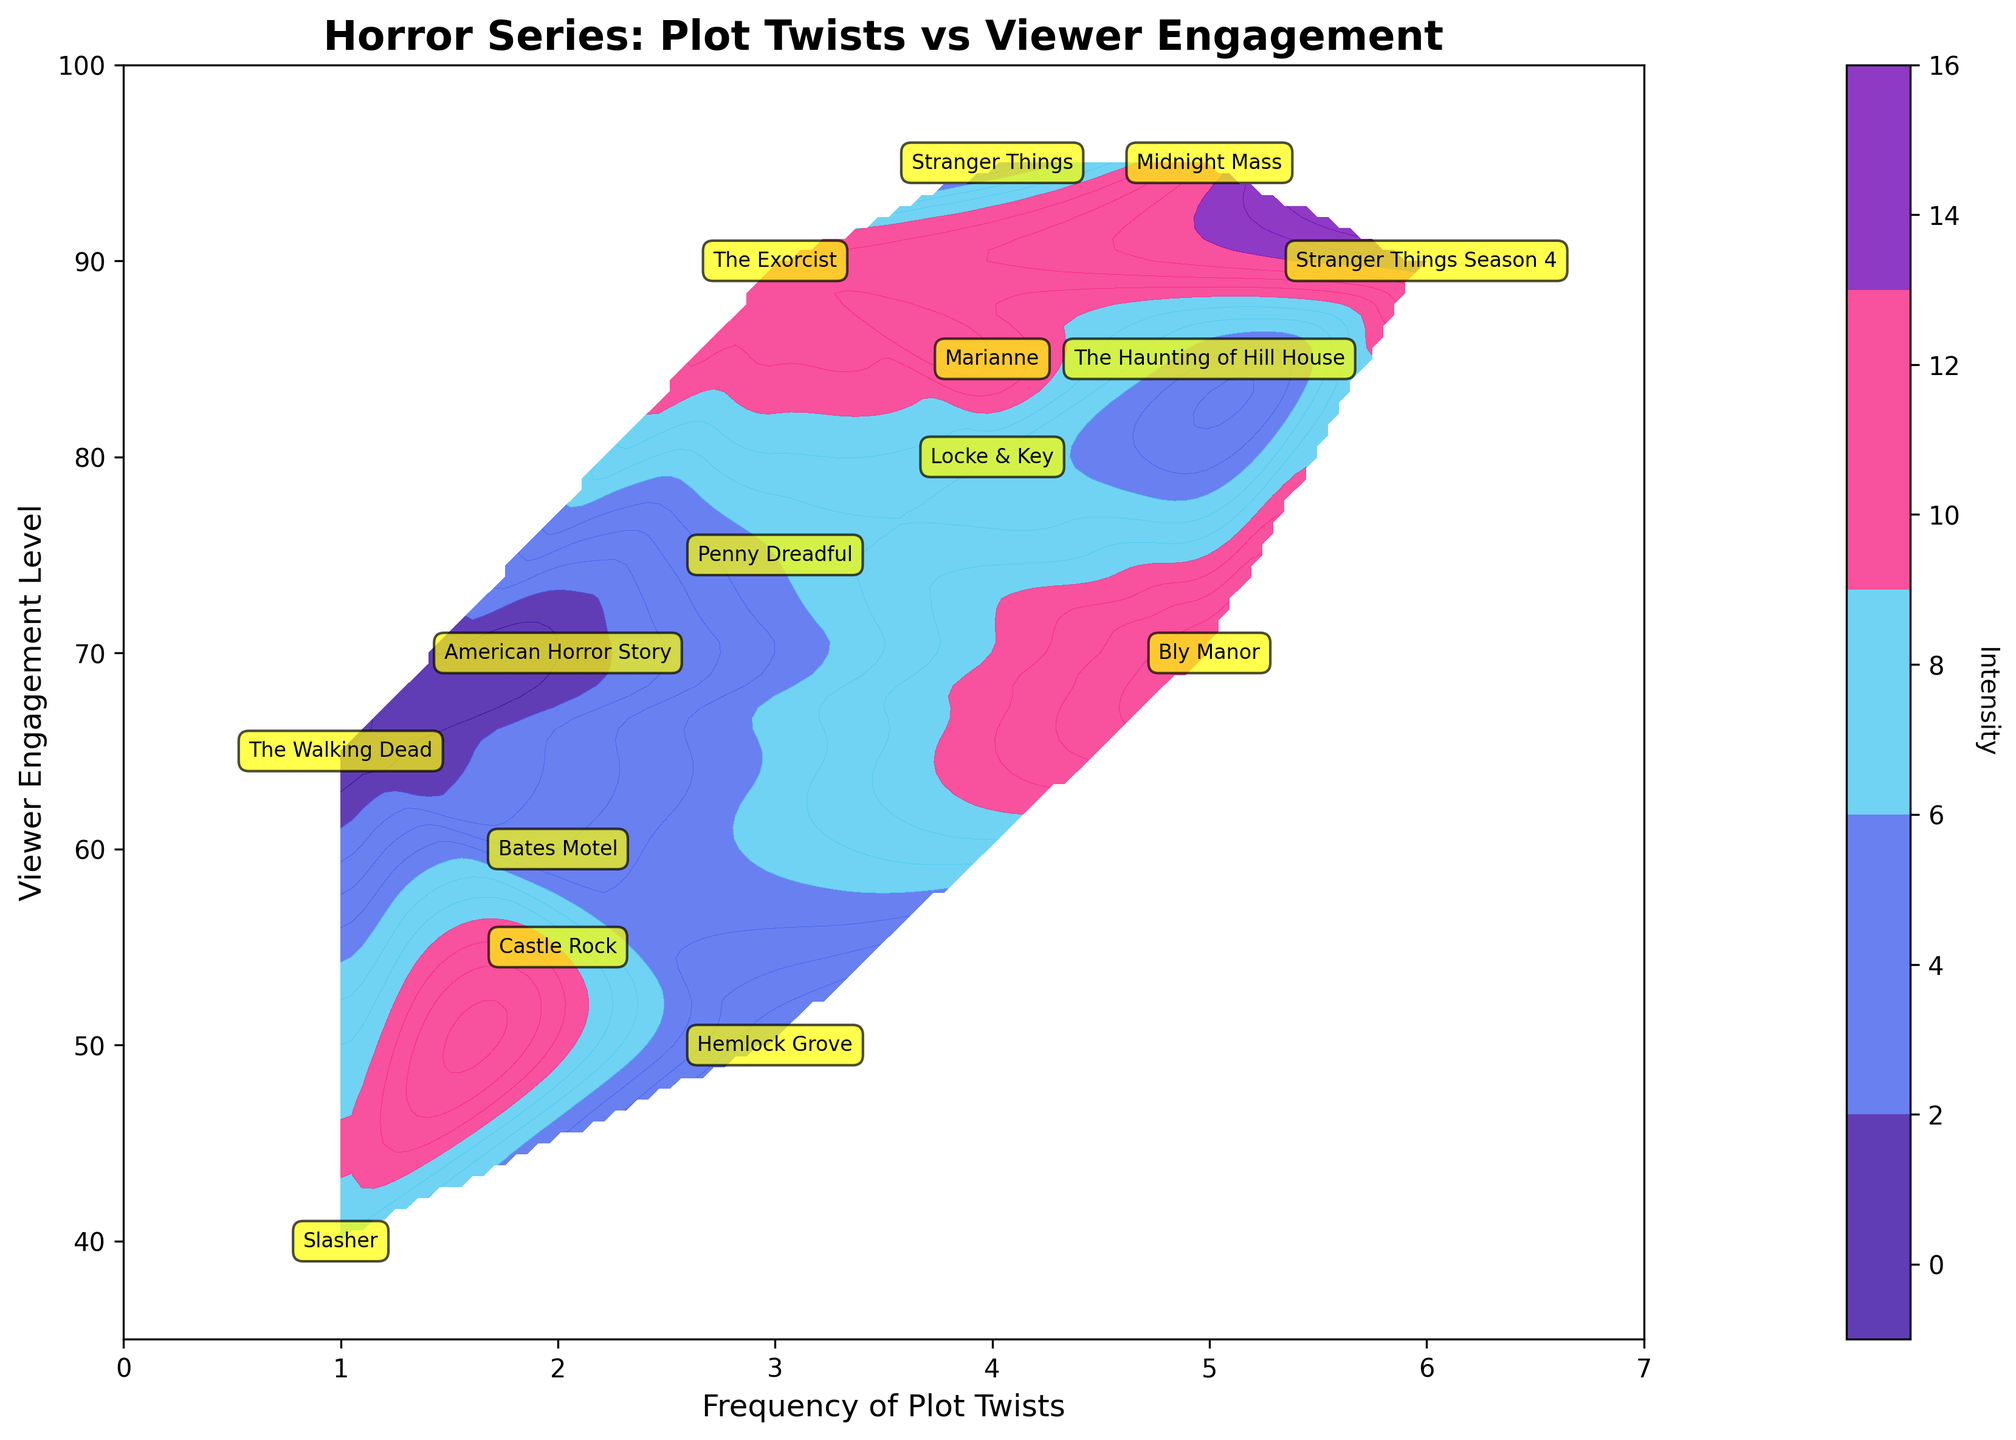What's the title of the figure? The title of the figure is usually displayed prominently at the top. In this case, it reads "Horror Series: Plot Twists vs Viewer Engagement", which summarizes what the graph is about.
Answer: Horror Series: Plot Twists vs Viewer Engagement How many series have a frequency of plot twists equal to 5? Look for the label numbers along the x-axis representing the Frequency of Plot Twists, and then count the labeled series names that are aligned with the value 5. We'll see "The Haunting of Hill House", "Midnight Mass", and "Bly Manor".
Answer: 3 Which horror series shows the highest viewer engagement level? Find the highest value on the y-axis (Viewer Engagement Level) and look for the series name labeled at this value. The series at the peak value of 95 is "Stranger Things" and "Midnight Mass".
Answer: Stranger Things and Midnight Mass What is the engagement level of "The Walking Dead"? Locate "The Walking Dead" from the labeled series names and note its corresponding position on the y-axis. The label is at the value 65 on the y-axis, indicating its viewer engagement level.
Answer: 65 Among the series listed, which one has the lowest viewer engagement level? Identify the lowest value on the y-axis and check the labeled series name aligned with this value. The series at the minimum value of 40 is "Slasher".
Answer: Slasher Compare the viewer engagement levels of "American Horror Story" and "Bates Motel". Which one is higher? Locate "American Horror Story" and "Bates Motel" from the labeled series names and compare their vertical positions on the y-axis. "American Horror Story" is at 70, while "Bates Motel" is at 60.
Answer: American Horror Story When the frequency of plot twists is 3, what are the engagement levels of the associated series? Look for the x-axis value of 3 and identify the series names located there. The series names are "Hemlock Grove", "Penny Dreadful", and "The Exorcist", with viewer engagement levels of 50, 75, and 90, respectively.
Answer: 50, 75, and 90 Which series shows a viewer engagement level of 80? Scan the y-axis for the value of 80 and find the series name labeled at this point. The series name at the value of 80 is "Locke & Key".
Answer: Locke & Key Do series with higher frequencies of plot twists tend to have higher engagement levels? Assess the overall trend in the contour plot, looking at how viewer engagement levels change as you move from lower to higher values on the x-axis (Frequency of Plot Twists). Generally, there seems to be an upward trend, suggesting increased engagement with higher plot twist frequencies.
Answer: Yes 